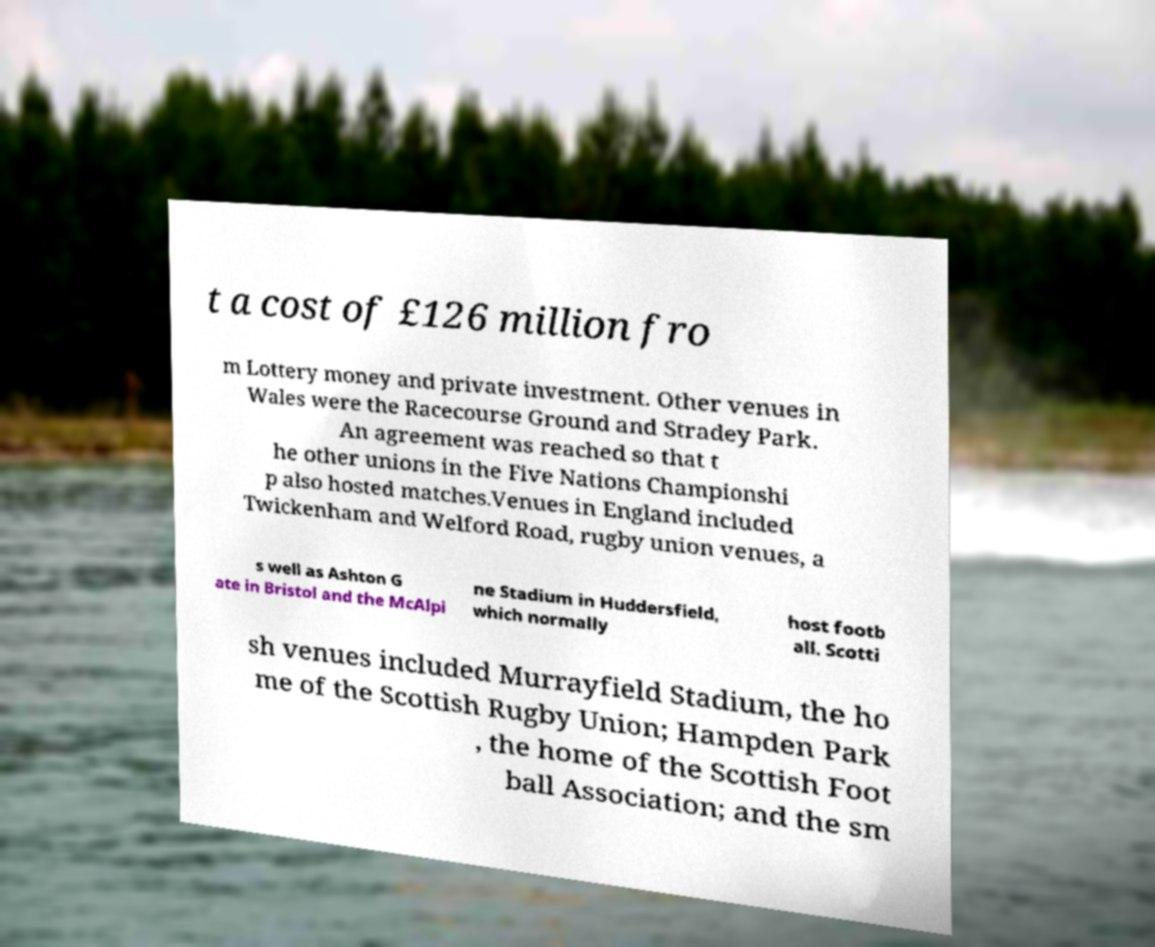I need the written content from this picture converted into text. Can you do that? t a cost of £126 million fro m Lottery money and private investment. Other venues in Wales were the Racecourse Ground and Stradey Park. An agreement was reached so that t he other unions in the Five Nations Championshi p also hosted matches.Venues in England included Twickenham and Welford Road, rugby union venues, a s well as Ashton G ate in Bristol and the McAlpi ne Stadium in Huddersfield, which normally host footb all. Scotti sh venues included Murrayfield Stadium, the ho me of the Scottish Rugby Union; Hampden Park , the home of the Scottish Foot ball Association; and the sm 